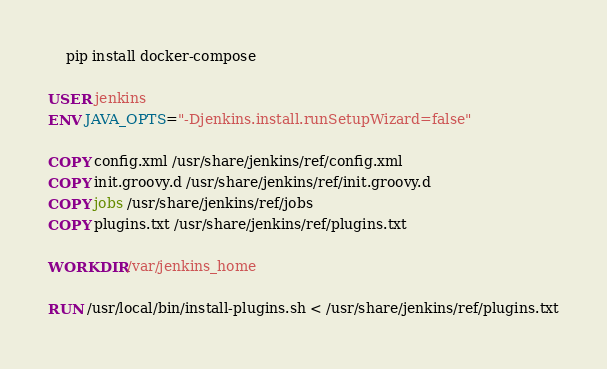Convert code to text. <code><loc_0><loc_0><loc_500><loc_500><_Dockerfile_>    pip install docker-compose

USER jenkins
ENV JAVA_OPTS="-Djenkins.install.runSetupWizard=false"

COPY config.xml /usr/share/jenkins/ref/config.xml
COPY init.groovy.d /usr/share/jenkins/ref/init.groovy.d
COPY jobs /usr/share/jenkins/ref/jobs
COPY plugins.txt /usr/share/jenkins/ref/plugins.txt

WORKDIR /var/jenkins_home

RUN /usr/local/bin/install-plugins.sh < /usr/share/jenkins/ref/plugins.txt
</code> 